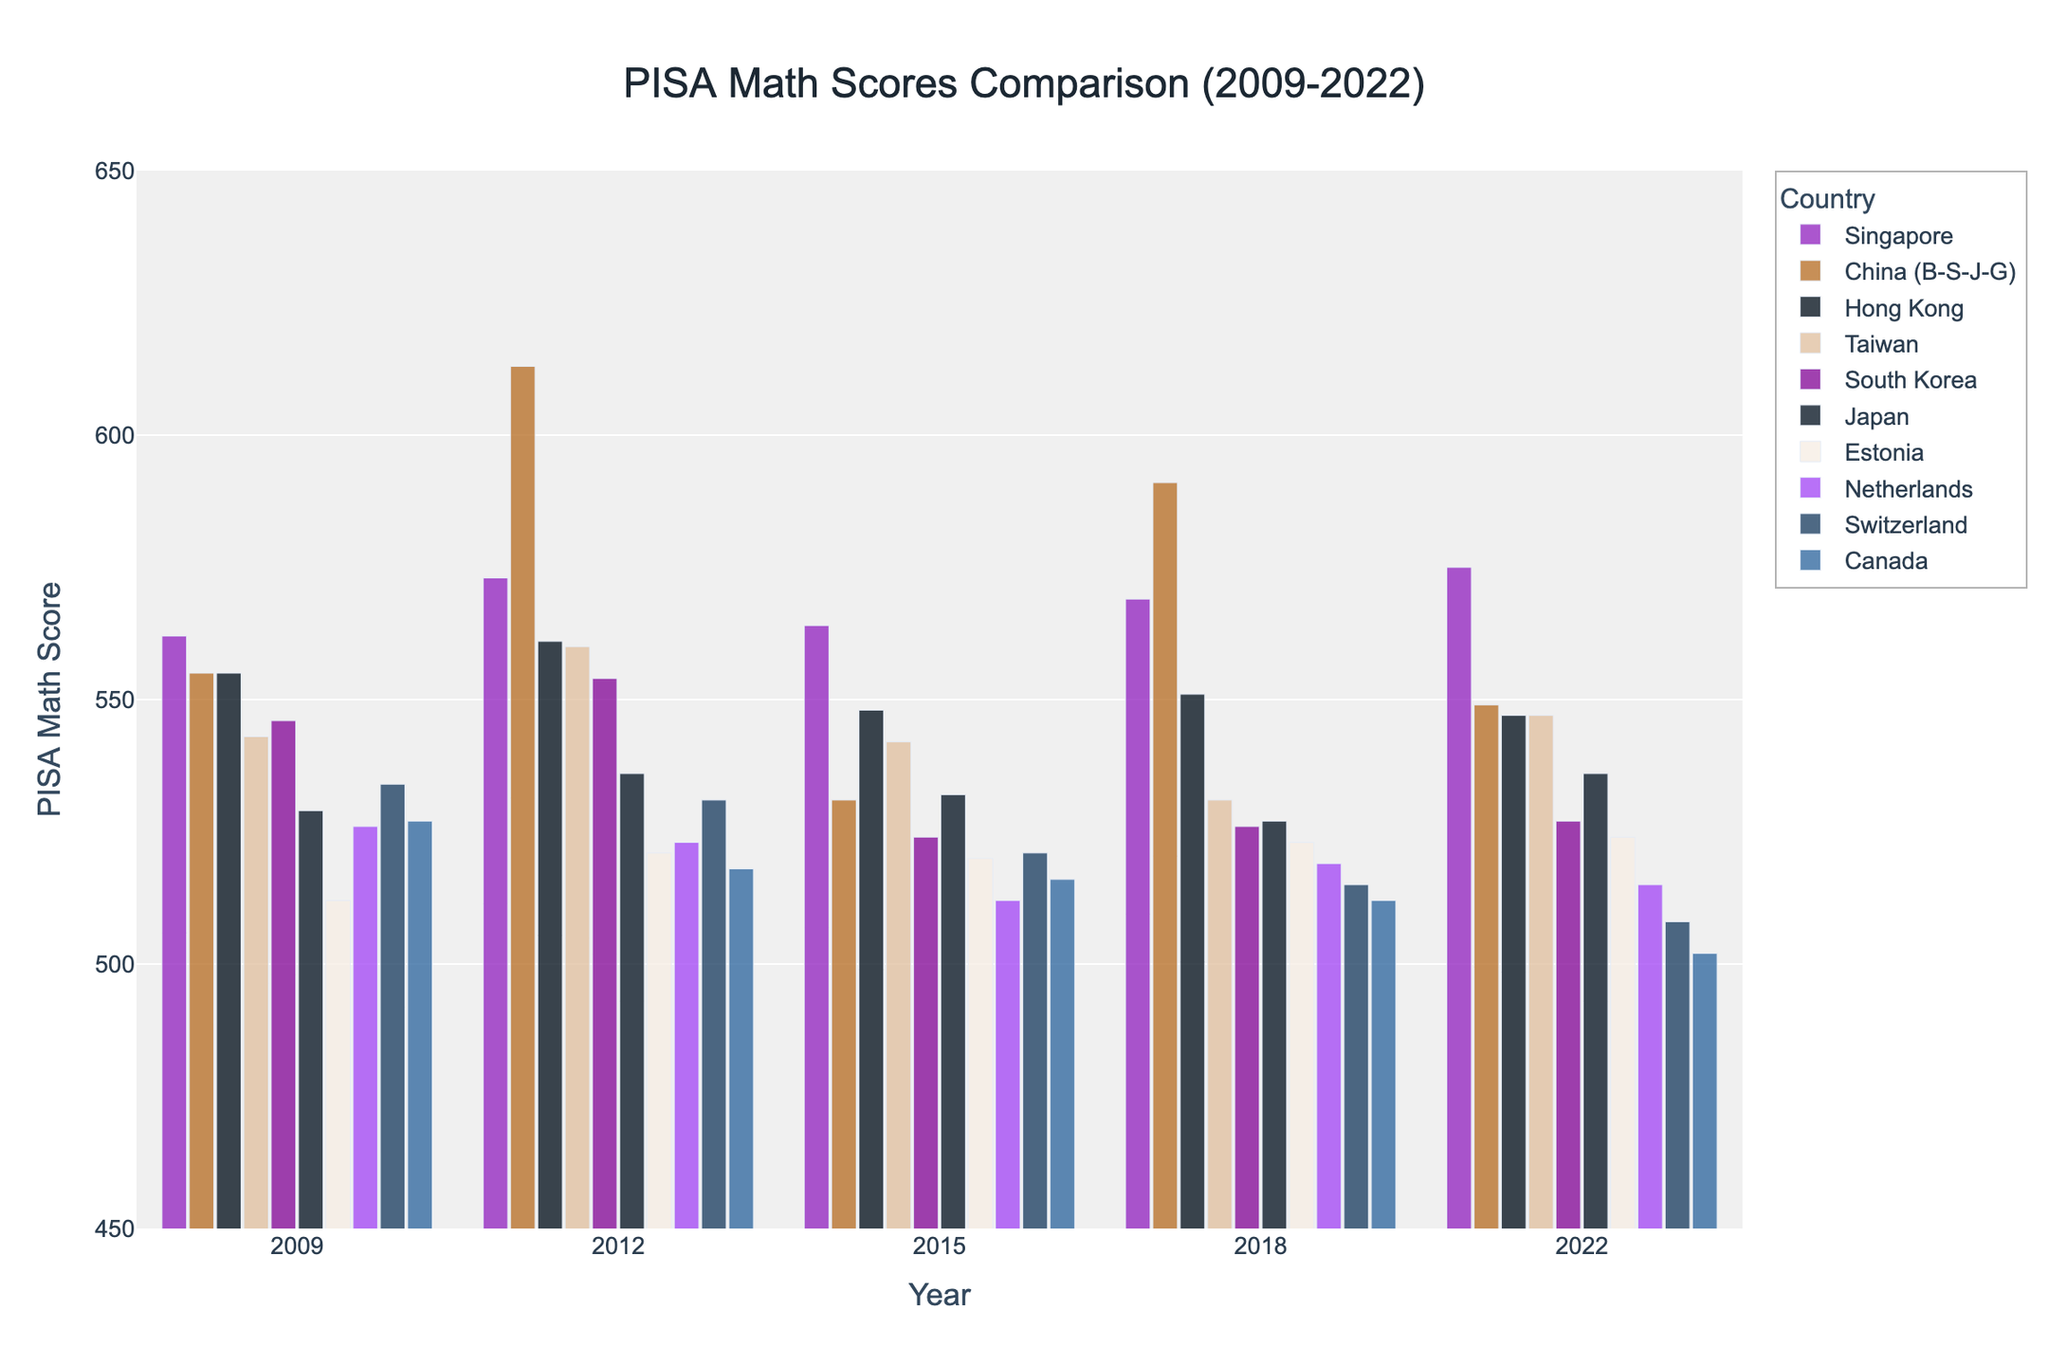Which country had the highest PISA math score in 2022? To find the highest PISA math score in 2022, look at the bar heights in the 2022 section of the chart. Singapore has the highest bar.
Answer: Singapore How did Japan's PISA math score change from 2009 to 2022? Compare the bar height for Japan in 2009 and 2022. In 2009, Japan's score was 529, and in 2022, it was 536. The difference is 536 - 529.
Answer: Increased by 7 points Which countries showed a decline in PISA math scores from 2018 to 2022? For each country, compare the bar heights from 2018 to 2022. China (B-S-J-G), Hong Kong, South Korea, and Canada showed decreases in their scores.
Answer: China, Hong Kong, South Korea, Canada What is the average PISA math score of Singapore over the 5 assessments? Sum the scores of Singapore from 2009, 2012, 2015, 2018, and 2022 and then divide by 5: (562 + 573 + 564 + 569 + 575) / 5
Answer: 568.6 Which country had the most fluctuation in its PISA math scores between 2009 and 2022? To find the most fluctuation, calculate the range (max - min) for each country. China (B-S-J-G) had a range of 613 - 531 = 82, the largest fluctuation.
Answer: China How does Estonia's PISA math score in 2022 compare to the average score of all countries in that year? First, calculate the average of all countries' scores in 2022: (575 + 549 + 547 + 547 + 527 + 536 + 524 + 515 + 508 + 502) / 10 = 523, then compare to Estonia's score 524.
Answer: 1 point higher Which year did Canada have the lowest PISA math score? Look for the shortest bar for Canada. The lowest score is in 2022 with a score of 502.
Answer: 2022 How many countries had a higher PISA math score than Estonia in 2022? Estonia’s score in 2022 is 524. Count the countries with a higher score: Singapore, China, Hong Kong, Taiwan, South Korea, and Japan have higher scores. So, 6 countries.
Answer: 6 By how many points did South Korea’s PISA math score decrease from 2012 to 2015? Compare South Korea's scores from 2012 (554) to 2015 (524). The decrease is 554 - 524.
Answer: 30 points Between which years did Hong Kong show the smallest change in PISA math scores? Look for the smallest difference in scores for consecutive years for Hong Kong: It shows a change of only 1 point from 2015 (548) to 2018 (551).
Answer: 2015 to 2018 